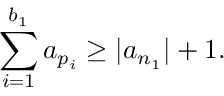Convert formula to latex. <formula><loc_0><loc_0><loc_500><loc_500>\sum _ { i = 1 } ^ { b _ { 1 } } a _ { p _ { i } } \geq | a _ { n _ { 1 } } | + 1 .</formula> 